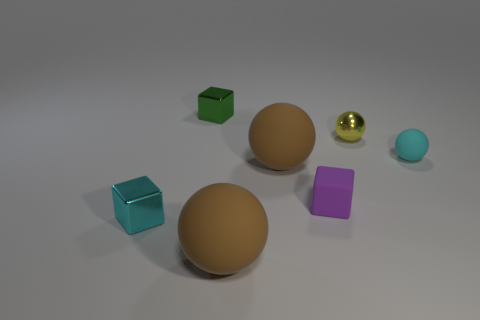Subtract all yellow balls. How many balls are left? 3 Subtract all purple cylinders. How many brown spheres are left? 2 Add 1 tiny brown things. How many objects exist? 8 Subtract 2 balls. How many balls are left? 2 Subtract all yellow balls. How many balls are left? 3 Subtract all red blocks. Subtract all purple balls. How many blocks are left? 3 Subtract 0 red cylinders. How many objects are left? 7 Subtract all blocks. How many objects are left? 4 Subtract all gray cylinders. Subtract all cyan rubber things. How many objects are left? 6 Add 3 big brown matte things. How many big brown matte things are left? 5 